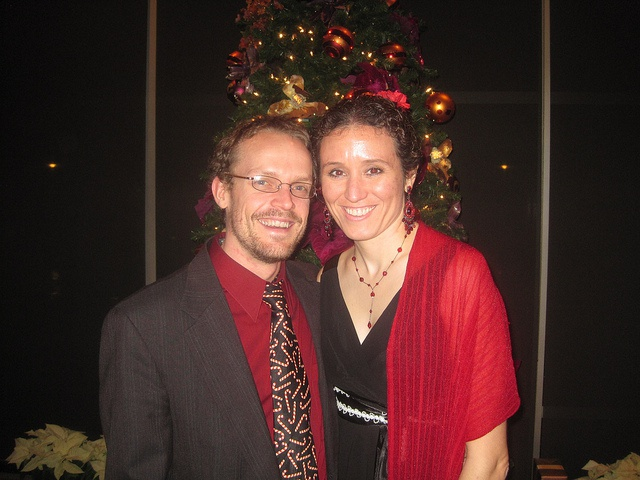Describe the objects in this image and their specific colors. I can see people in black, brown, and tan tones, people in black, brown, and salmon tones, and tie in black, maroon, and gray tones in this image. 